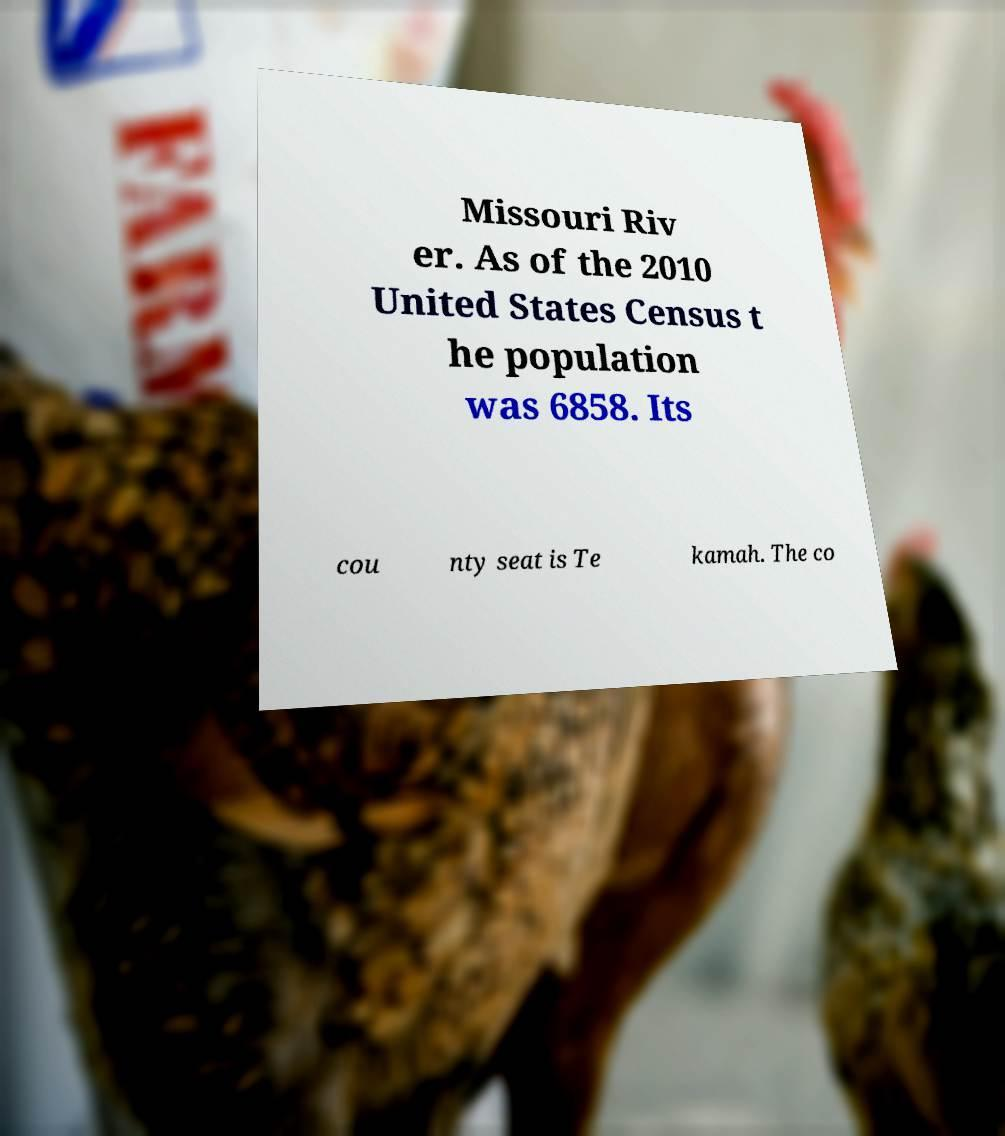There's text embedded in this image that I need extracted. Can you transcribe it verbatim? Missouri Riv er. As of the 2010 United States Census t he population was 6858. Its cou nty seat is Te kamah. The co 